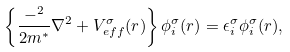<formula> <loc_0><loc_0><loc_500><loc_500>\left \{ \frac { - { } ^ { 2 } } { 2 m ^ { * } } { \nabla } ^ { 2 } + V ^ { \sigma } _ { e f f } ( { r } ) \right \} \phi ^ { \sigma } _ { i } ( { r } ) = \epsilon ^ { \sigma } _ { i } \phi ^ { \sigma } _ { i } ( { r } ) ,</formula> 